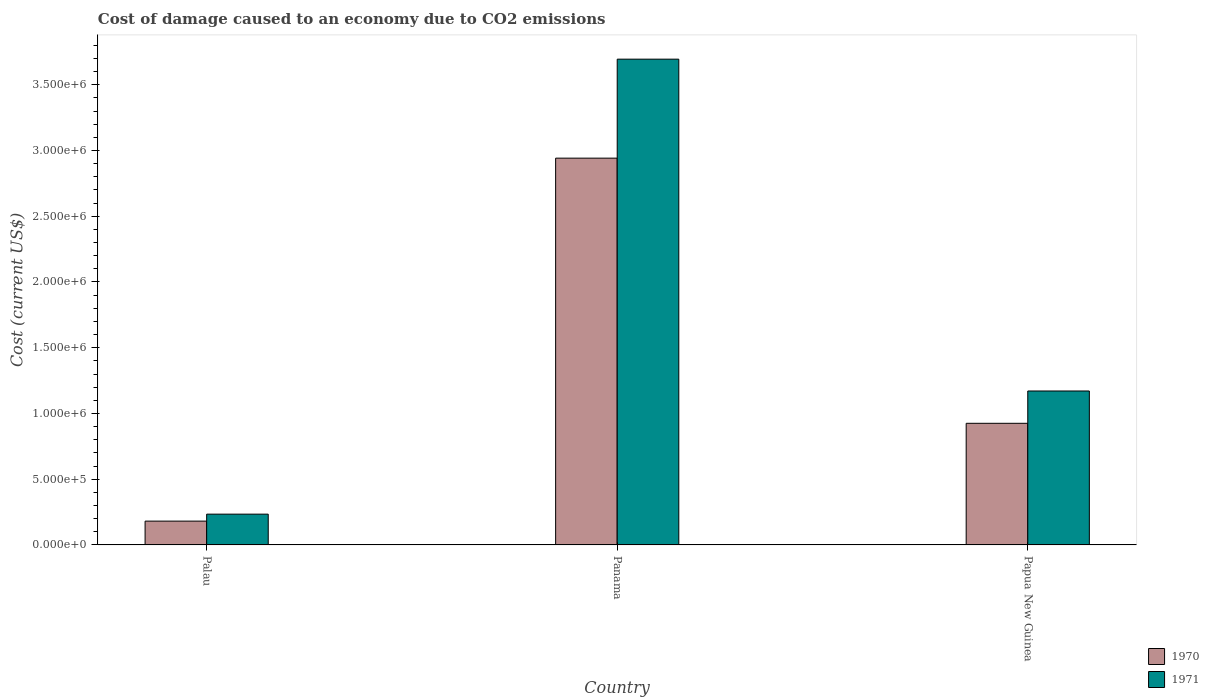Are the number of bars per tick equal to the number of legend labels?
Provide a succinct answer. Yes. Are the number of bars on each tick of the X-axis equal?
Ensure brevity in your answer.  Yes. What is the label of the 3rd group of bars from the left?
Ensure brevity in your answer.  Papua New Guinea. What is the cost of damage caused due to CO2 emissisons in 1970 in Papua New Guinea?
Provide a succinct answer. 9.25e+05. Across all countries, what is the maximum cost of damage caused due to CO2 emissisons in 1971?
Provide a succinct answer. 3.69e+06. Across all countries, what is the minimum cost of damage caused due to CO2 emissisons in 1970?
Offer a very short reply. 1.81e+05. In which country was the cost of damage caused due to CO2 emissisons in 1971 maximum?
Give a very brief answer. Panama. In which country was the cost of damage caused due to CO2 emissisons in 1971 minimum?
Your response must be concise. Palau. What is the total cost of damage caused due to CO2 emissisons in 1970 in the graph?
Your answer should be very brief. 4.05e+06. What is the difference between the cost of damage caused due to CO2 emissisons in 1971 in Palau and that in Panama?
Keep it short and to the point. -3.46e+06. What is the difference between the cost of damage caused due to CO2 emissisons in 1970 in Papua New Guinea and the cost of damage caused due to CO2 emissisons in 1971 in Palau?
Make the answer very short. 6.91e+05. What is the average cost of damage caused due to CO2 emissisons in 1971 per country?
Your answer should be compact. 1.70e+06. What is the difference between the cost of damage caused due to CO2 emissisons of/in 1971 and cost of damage caused due to CO2 emissisons of/in 1970 in Panama?
Provide a succinct answer. 7.53e+05. In how many countries, is the cost of damage caused due to CO2 emissisons in 1970 greater than 3600000 US$?
Your answer should be compact. 0. What is the ratio of the cost of damage caused due to CO2 emissisons in 1971 in Palau to that in Papua New Guinea?
Your response must be concise. 0.2. Is the cost of damage caused due to CO2 emissisons in 1971 in Palau less than that in Papua New Guinea?
Your answer should be very brief. Yes. Is the difference between the cost of damage caused due to CO2 emissisons in 1971 in Panama and Papua New Guinea greater than the difference between the cost of damage caused due to CO2 emissisons in 1970 in Panama and Papua New Guinea?
Offer a very short reply. Yes. What is the difference between the highest and the second highest cost of damage caused due to CO2 emissisons in 1970?
Your response must be concise. -7.44e+05. What is the difference between the highest and the lowest cost of damage caused due to CO2 emissisons in 1970?
Make the answer very short. 2.76e+06. Is the sum of the cost of damage caused due to CO2 emissisons in 1970 in Palau and Panama greater than the maximum cost of damage caused due to CO2 emissisons in 1971 across all countries?
Offer a terse response. No. What does the 1st bar from the right in Panama represents?
Your answer should be very brief. 1971. Are all the bars in the graph horizontal?
Your response must be concise. No. How many countries are there in the graph?
Offer a terse response. 3. Are the values on the major ticks of Y-axis written in scientific E-notation?
Your response must be concise. Yes. How many legend labels are there?
Your response must be concise. 2. What is the title of the graph?
Your answer should be very brief. Cost of damage caused to an economy due to CO2 emissions. What is the label or title of the X-axis?
Ensure brevity in your answer.  Country. What is the label or title of the Y-axis?
Ensure brevity in your answer.  Cost (current US$). What is the Cost (current US$) in 1970 in Palau?
Keep it short and to the point. 1.81e+05. What is the Cost (current US$) of 1971 in Palau?
Offer a very short reply. 2.34e+05. What is the Cost (current US$) of 1970 in Panama?
Your answer should be very brief. 2.94e+06. What is the Cost (current US$) of 1971 in Panama?
Make the answer very short. 3.69e+06. What is the Cost (current US$) of 1970 in Papua New Guinea?
Provide a short and direct response. 9.25e+05. What is the Cost (current US$) of 1971 in Papua New Guinea?
Provide a short and direct response. 1.17e+06. Across all countries, what is the maximum Cost (current US$) in 1970?
Offer a terse response. 2.94e+06. Across all countries, what is the maximum Cost (current US$) of 1971?
Provide a short and direct response. 3.69e+06. Across all countries, what is the minimum Cost (current US$) of 1970?
Offer a very short reply. 1.81e+05. Across all countries, what is the minimum Cost (current US$) of 1971?
Provide a succinct answer. 2.34e+05. What is the total Cost (current US$) of 1970 in the graph?
Offer a terse response. 4.05e+06. What is the total Cost (current US$) in 1971 in the graph?
Keep it short and to the point. 5.10e+06. What is the difference between the Cost (current US$) in 1970 in Palau and that in Panama?
Keep it short and to the point. -2.76e+06. What is the difference between the Cost (current US$) of 1971 in Palau and that in Panama?
Offer a terse response. -3.46e+06. What is the difference between the Cost (current US$) of 1970 in Palau and that in Papua New Guinea?
Provide a short and direct response. -7.44e+05. What is the difference between the Cost (current US$) of 1971 in Palau and that in Papua New Guinea?
Make the answer very short. -9.37e+05. What is the difference between the Cost (current US$) of 1970 in Panama and that in Papua New Guinea?
Offer a very short reply. 2.02e+06. What is the difference between the Cost (current US$) in 1971 in Panama and that in Papua New Guinea?
Your answer should be very brief. 2.52e+06. What is the difference between the Cost (current US$) in 1970 in Palau and the Cost (current US$) in 1971 in Panama?
Ensure brevity in your answer.  -3.51e+06. What is the difference between the Cost (current US$) of 1970 in Palau and the Cost (current US$) of 1971 in Papua New Guinea?
Provide a short and direct response. -9.90e+05. What is the difference between the Cost (current US$) of 1970 in Panama and the Cost (current US$) of 1971 in Papua New Guinea?
Give a very brief answer. 1.77e+06. What is the average Cost (current US$) of 1970 per country?
Offer a terse response. 1.35e+06. What is the average Cost (current US$) of 1971 per country?
Ensure brevity in your answer.  1.70e+06. What is the difference between the Cost (current US$) of 1970 and Cost (current US$) of 1971 in Palau?
Keep it short and to the point. -5.31e+04. What is the difference between the Cost (current US$) in 1970 and Cost (current US$) in 1971 in Panama?
Your answer should be compact. -7.53e+05. What is the difference between the Cost (current US$) in 1970 and Cost (current US$) in 1971 in Papua New Guinea?
Provide a succinct answer. -2.46e+05. What is the ratio of the Cost (current US$) in 1970 in Palau to that in Panama?
Provide a succinct answer. 0.06. What is the ratio of the Cost (current US$) in 1971 in Palau to that in Panama?
Your answer should be very brief. 0.06. What is the ratio of the Cost (current US$) in 1970 in Palau to that in Papua New Guinea?
Make the answer very short. 0.2. What is the ratio of the Cost (current US$) of 1970 in Panama to that in Papua New Guinea?
Offer a very short reply. 3.18. What is the ratio of the Cost (current US$) of 1971 in Panama to that in Papua New Guinea?
Offer a terse response. 3.16. What is the difference between the highest and the second highest Cost (current US$) of 1970?
Provide a succinct answer. 2.02e+06. What is the difference between the highest and the second highest Cost (current US$) of 1971?
Your answer should be compact. 2.52e+06. What is the difference between the highest and the lowest Cost (current US$) of 1970?
Provide a short and direct response. 2.76e+06. What is the difference between the highest and the lowest Cost (current US$) in 1971?
Your response must be concise. 3.46e+06. 